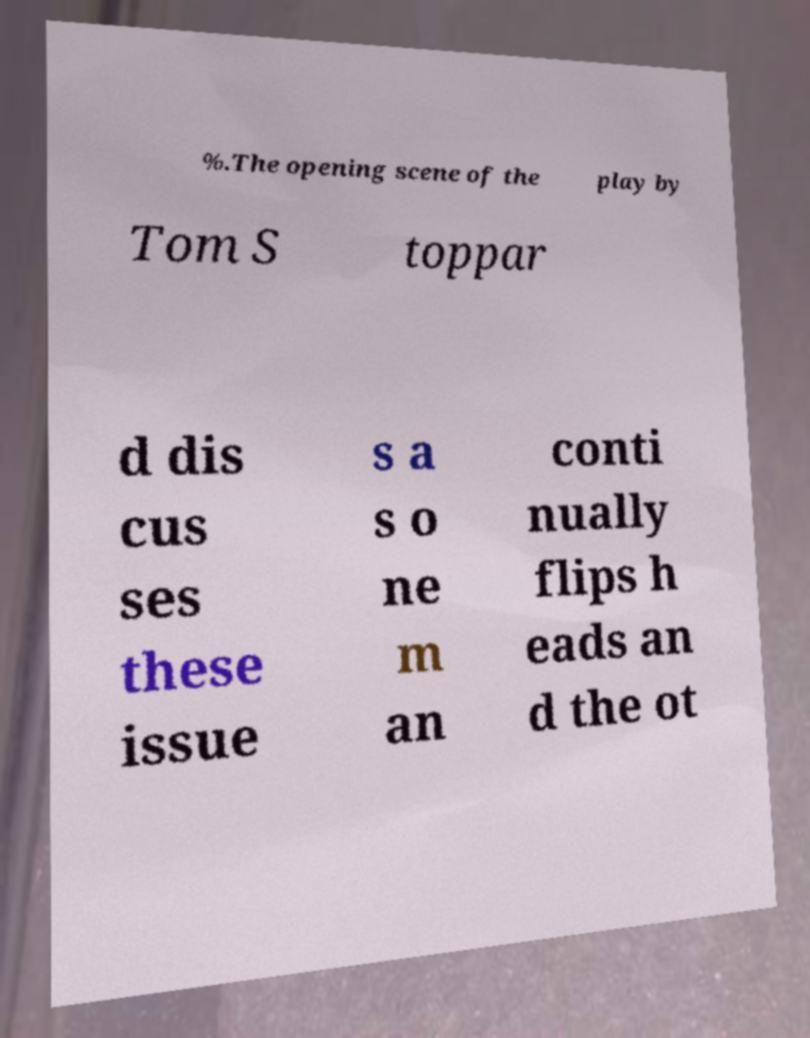Can you read and provide the text displayed in the image?This photo seems to have some interesting text. Can you extract and type it out for me? %.The opening scene of the play by Tom S toppar d dis cus ses these issue s a s o ne m an conti nually flips h eads an d the ot 